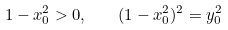<formula> <loc_0><loc_0><loc_500><loc_500>1 - x _ { 0 } ^ { 2 } > 0 , \quad ( 1 - x _ { 0 } ^ { 2 } ) ^ { 2 } = y _ { 0 } ^ { 2 }</formula> 